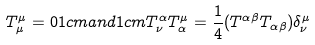Convert formula to latex. <formula><loc_0><loc_0><loc_500><loc_500>T _ { \mu } ^ { \mu } = 0 1 c m a n d 1 c m T _ { \nu } ^ { \alpha } T _ { \alpha } ^ { \mu } = \frac { 1 } { 4 } ( T ^ { \alpha \beta } T _ { \alpha \beta } ) \delta _ { \nu } ^ { \mu }</formula> 